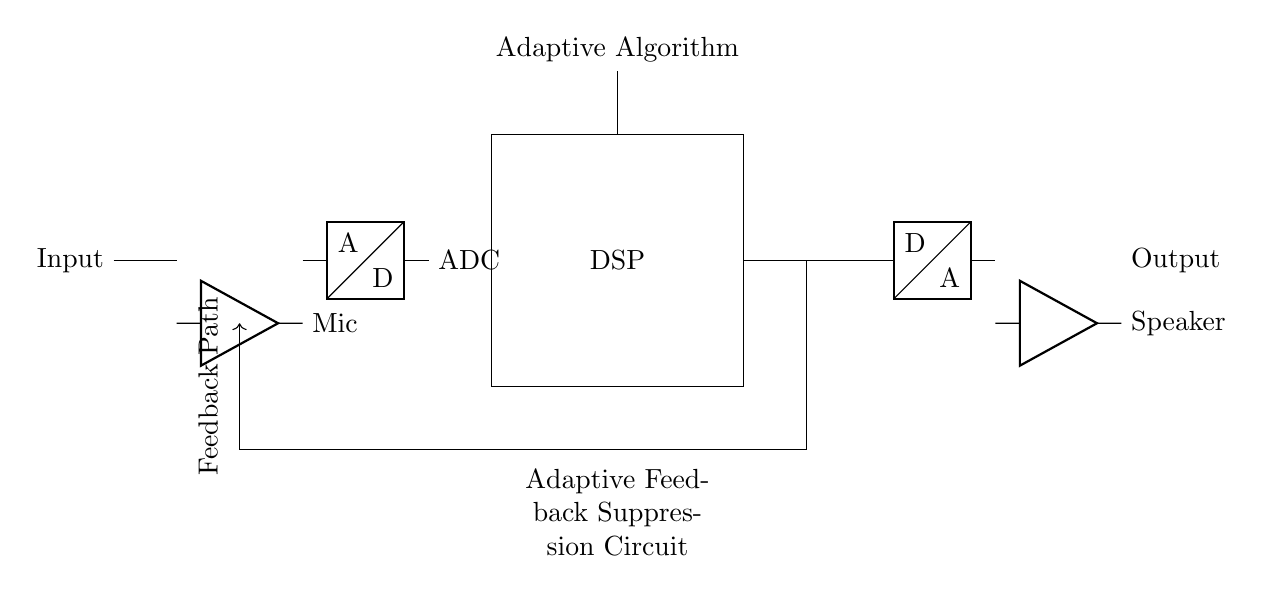What is the function of the component labeled "Mic"? The "Mic" stands for microphone, which converts sound waves into electrical signals for further processing in the hearing aid circuit.
Answer: Microphone What does "DSP" stand for in this circuit? "DSP" stands for Digital Signal Processor, which handles signal processing through adaptive algorithms to suppress feedback.
Answer: Digital Signal Processor How many main blocks are shown in the circuit? The circuit diagram consists of four main functional blocks: Mic, ADC, DSP, and DAC.
Answer: Four What does the feedback path do in this circuit? The feedback path connects the output back to the DSP, allowing the circuit to adjust the gain and suppress feedback, preventing whistling in hearing aids.
Answer: Prevents whistling Why is there an ADC in the circuit? The ADC (Analog-to-Digital Converter) translates the analog signals from the microphone into digital format for processing in the DSP.
Answer: Converts analog to digital What is the purpose of the DAC in this circuit? The DAC (Digital-to-Analog Converter) transforms the processed digital signals back into analog form for output through the speaker.
Answer: Converts digital to analog What role does the adaptive algorithm play in the DSP? The adaptive algorithm adjusts the parameters within the DSP dynamically to improve feedback suppression effectiveness, responding to changing sound environments.
Answer: Enhances feedback suppression 